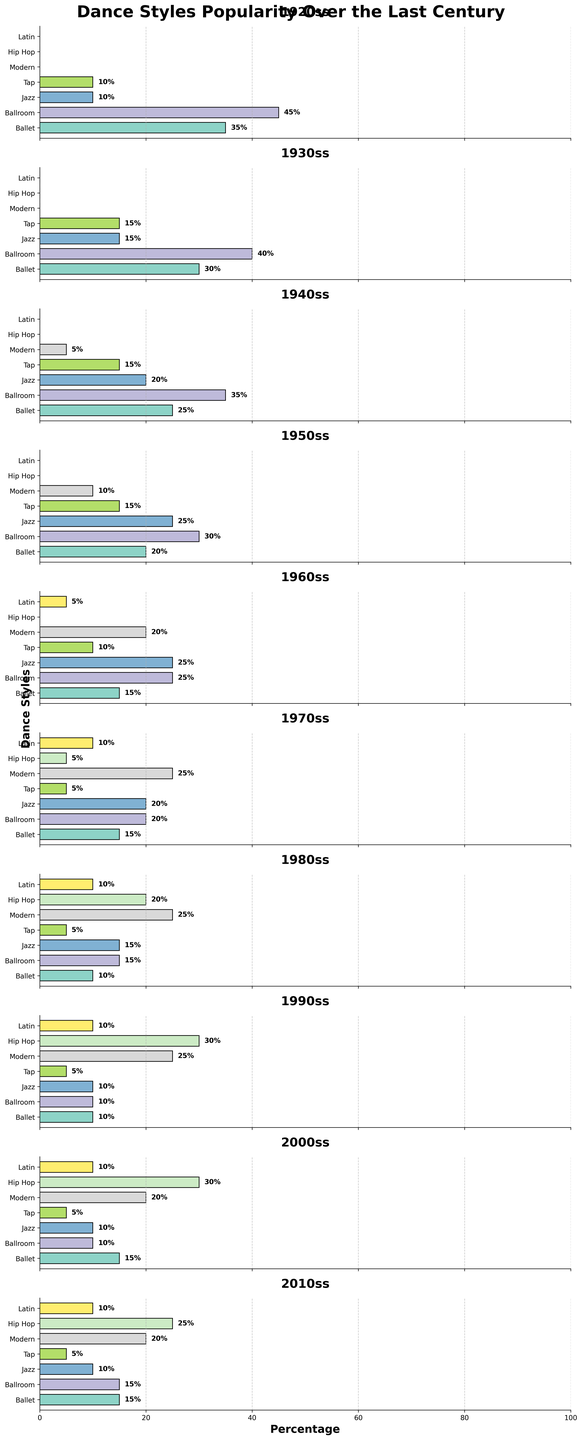Which decade had the highest popularity for Hip Hop? By examining the graph for each decade, the highest percentage bar for Hip Hop occurs in the 1990s at 30%.
Answer: 1990s Which dance style experienced a general decline in popularity from the 1920s to the 2010s? By looking at the bars for each decade, Ballet and Tap showed a decrease in their heights from the 1920s to the 2010s.
Answer: Ballet and Tap Among the dance styles, which one maintained a consistent popularity from the 1980s to the 2010s? By scanning the graph for consistent bar heights, Modern dance remained at 25% from the 1980s to the 2010s.
Answer: Modern Which dance style had the significant increase in popularity between the 1930s and the 1940s? Jazz had bars increasing from 15% in the 1930s to 20% in the 1940s, which is a noticeable increase.
Answer: Jazz Which dance style had the least popularity in the 1970s? Tap had the shortest bar in the 1970s with a percentage of 5%.
Answer: Tap What is the average popularity of Ballroom dance across all decades? Summing up the percentages for Ballroom dance (45 + 40 + 35 + 30 + 25 + 20 + 15 + 10 + 10 + 15) and dividing by the number of decades (10), the average is (245 / 10) = 24.5%.
Answer: 24.5% How did the popularity of Latin dance change from the 1960s to the 2010s? Latin dance increased from 5% in the 1960s to 10% in the 2010s.
Answer: Increased Did any dance style reach exactly 25% popularity in the 2010s? By checking the heights of the bars in the 2010s graph, only Modern dance had a popularity of 25%.
Answer: Modern What was the combined percentage of Ballet and Ballroom in the 1950s? Ballet had 20% and Ballroom had 30% in the 1950s, so combined it's 20 + 30 = 50%.
Answer: 50% 